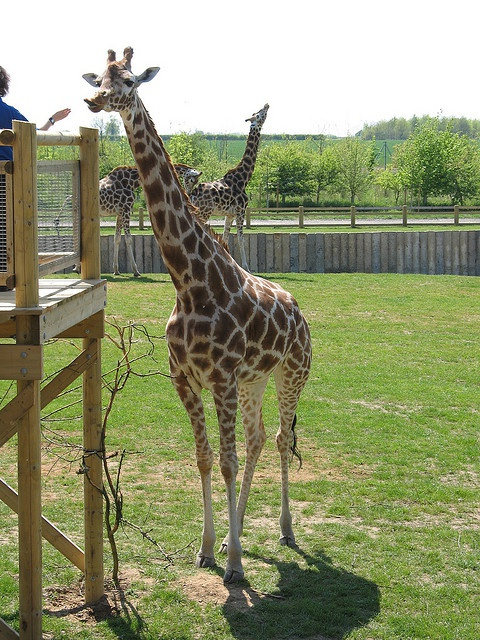Describe the objects in this image and their specific colors. I can see giraffe in white, gray, and black tones, giraffe in white, gray, black, and darkgray tones, giraffe in white, gray, black, and darkgray tones, and people in white, navy, gray, and black tones in this image. 